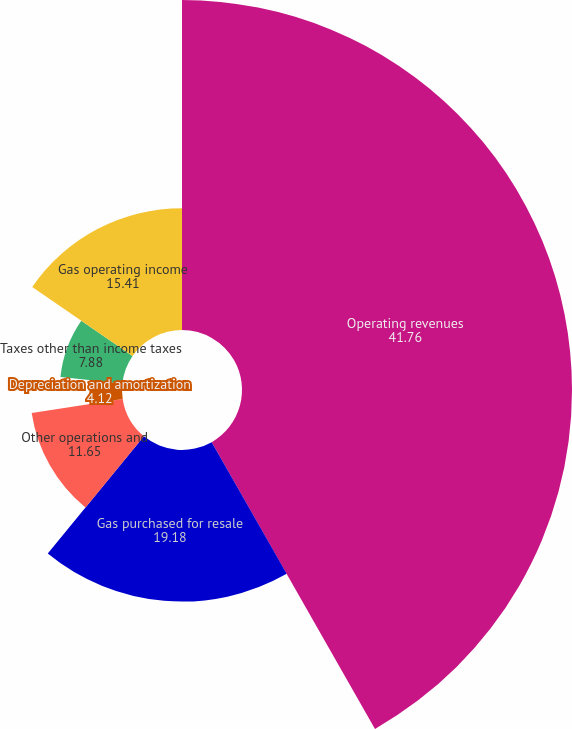<chart> <loc_0><loc_0><loc_500><loc_500><pie_chart><fcel>Operating revenues<fcel>Gas purchased for resale<fcel>Other operations and<fcel>Depreciation and amortization<fcel>Taxes other than income taxes<fcel>Gas operating income<nl><fcel>41.76%<fcel>19.18%<fcel>11.65%<fcel>4.12%<fcel>7.88%<fcel>15.41%<nl></chart> 